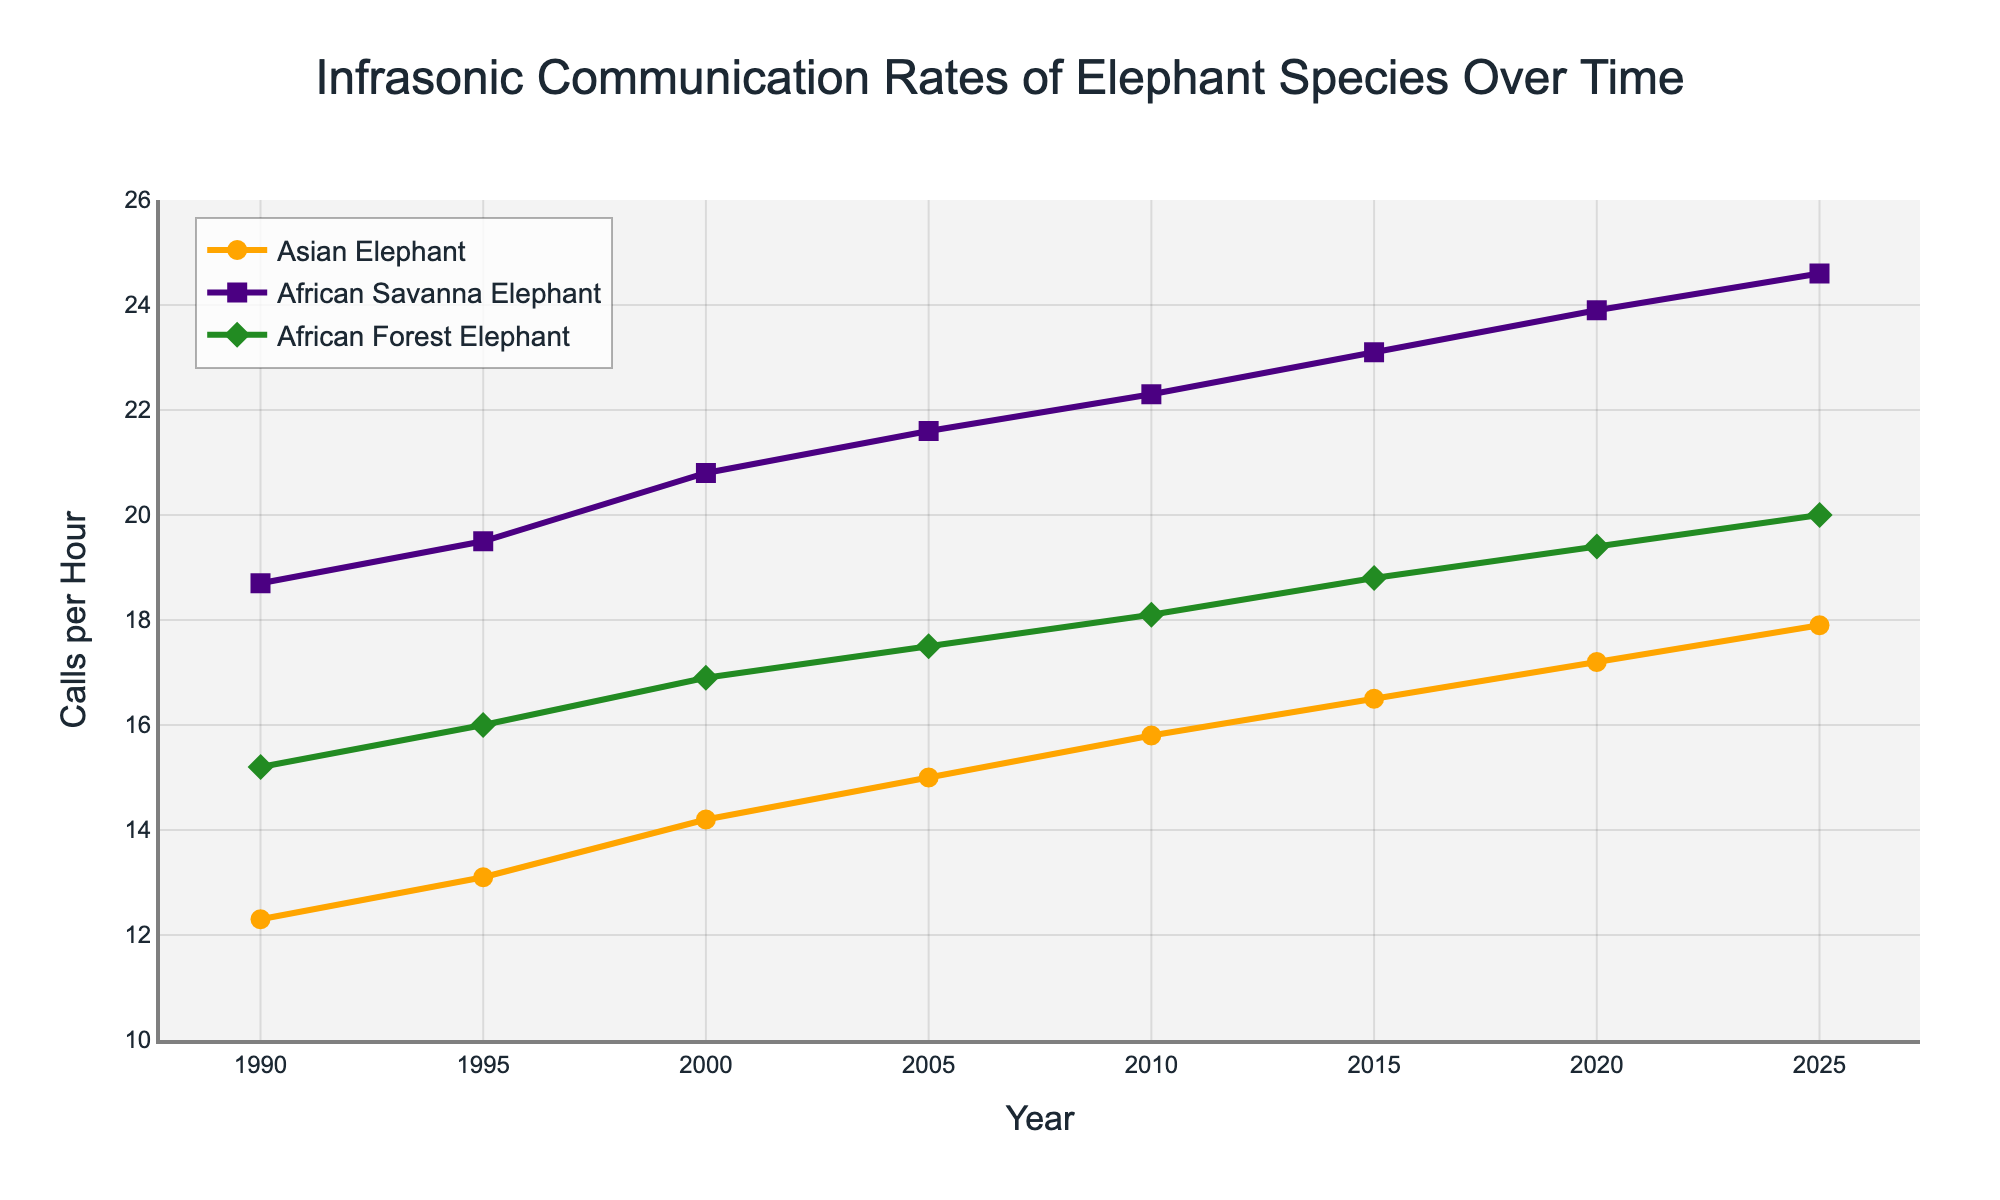What is the overall trend for the infrasonic communication rates of Asian elephants from 1990 to 2025? The infrasonic communication rate of Asian elephants shows a steady increase from 12.3 calls/hour in 1990 to 17.9 calls/hour in 2025.
Answer: Steady increase In 2015, which elephant species had the highest infrasonic communication rate? In 2015, the African Savanna Elephant had 23.1 calls/hour, the highest among the three species.
Answer: African Savanna Elephant How much did the infrasonic communication rate for African Forest Elephants change between 1990 and 2020? The infrasonic communication rate for African Forest Elephants increased from 15.2 calls/hour in 1990 to 19.4 calls/hour in 2020, a change of 4.2 calls/hour.
Answer: 4.2 calls/hour Which year saw the smallest difference in infrasonic communication rates between Asian Elephants and African Savanna Elephants? To find the smallest difference, check each year: 1990: 6.4, 1995: 6.4, 2000: 6.6, 2005: 6.6, 2010: 6.5, 2015: 6.6, 2020: 6.7, 2025: 6.7. The smallest difference is 6.4 in 1990 and 1995.
Answer: 1990 and 1995 Between 2000 and 2015, how many calls per hour did the infrasonic communication rate for Asian Elephants increase? The infrasonic communication rate for Asian Elephants increased from 14.2 calls/hour in 2000 to 16.5 calls/hour in 2015, a difference of 2.3 calls/hour.
Answer: 2.3 calls/hour Compare the infrasonic communication rates of African Forest Elephants and Asian Elephants in 2010. Which is higher and by how much? In 2010, African Forest Elephants had 18.1 calls/hour, while Asian Elephants had 15.8 calls/hour. African Forest Elephants' rate is higher by 2.3 calls/hour.
Answer: African Forest Elephants by 2.3 calls/hour What is the average infrasonic communication rate for African Savanna Elephants from 1990 to 2025? Sum up the rates: (18.7 + 19.5 + 20.8 + 21.6 + 22.3 + 23.1 + 23.9 + 24.6) = 174.5, divided by the number of years (8), the average is 174.5/8 = 21.8125.
Answer: 21.8 calls/hour Which species had the highest growth in infrasonic communication rates from 1990 to 2025? Calculate the growth for each species: Asian Elephants (17.9 - 12.3 = 5.6), African Savanna Elephants (24.6 - 18.7 = 5.9), African Forest Elephants (20.0 - 15.2 = 4.8). African Savanna Elephants had the highest growth of 5.9 calls/hour.
Answer: African Savanna Elephants What is the infrasonic communication rate for African Forest Elephants in 2025? The figure shows that the infrasonic communication rate for African Forest Elephants in 2025 is 20.0 calls/hour.
Answer: 20.0 calls/hour Between 1990 and 2020, which elephant species shows the most consistent increase in infrasonic communication rates? All three species show increases, but the trend lines for Asian Elephants and African Savanna Elephants appear more consistent and linear compared to African Forest Elephants.
Answer: Asian Elephants and African Savanna Elephants 